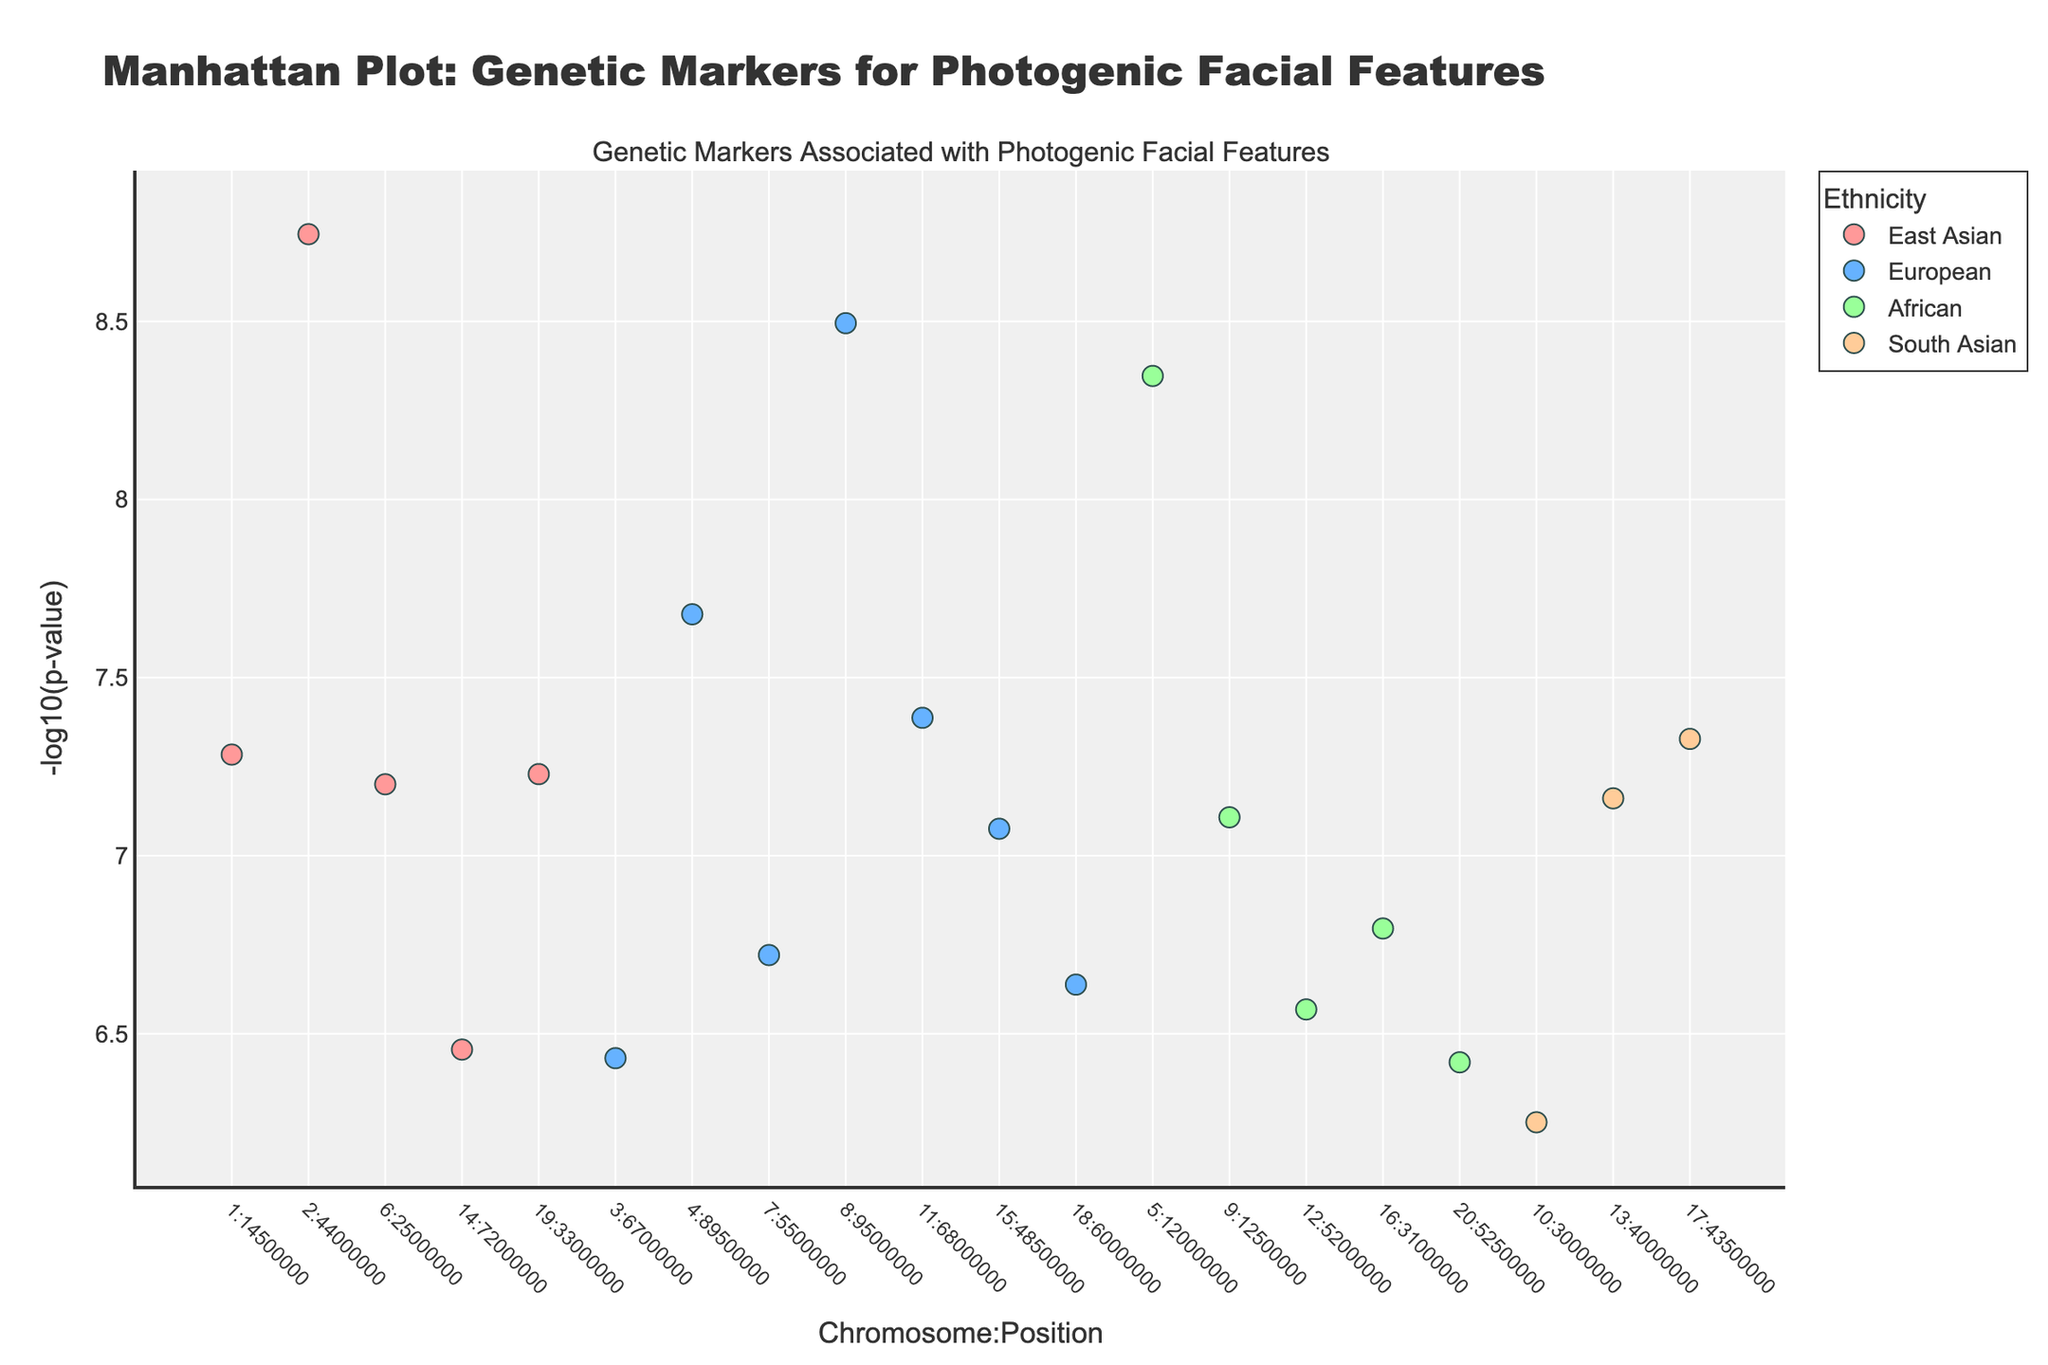What is the title of the plot? The title is located at the top of the plot and summarizes the content of the figure. It reads "Manhattan Plot: Genetic Markers for Photogenic Facial Features."
Answer: Manhattan Plot: Genetic Markers for Photogenic Facial Features How many data points represent European ethnicity? Identify all points within the legend labeled "European." Each color on the plot represents a different ethnicity, and there are six data points for European ethnicity.
Answer: 6 Which chromosome has the gene with the lowest P-value for East Asian ethnicity? To determine this, look for the East Asian markers (red points) and identify the point that is highest (represents lowest P-value). The gene with the lowest P-value is EDAR on chromosome 2.
Answer: Chromosome 2 What is the -log10(P-value) of the gene on Chromosome 1 for East Asian ethnicity? Identify the red points (East Asian ethnicity) on Chromosome 1 and read the y-value off the plot. The P-value for the MFAP2 gene on Chromosome 1 is 5.2e-8, so -log10(P-value) would be around 7.28.
Answer: 7.28 Which ethnicities have genetic markers on Chromosome 5? Look for points on Chromosome 5 and identify their colors. The plot shows markers for African (green).
Answer: African Which ethnicity has the most genes associated with photogenic facial features? Count the number of data points for each ethnicity according to the legend. European ethnicity has the most points with a total of six.
Answer: European Is there a genetic marker on Chromosome 10? If yes, what ethnicity does it belong to? Look for any markers on Chromosome 10. There is one marker, identified by its color (orange), indicating it belongs to South Asian ethnicity.
Answer: South Asian Which gene on Chromosome 7 has the highest -log10(P-value) and to which ethnicity does it belong? Identify the point on Chromosome 7 and read its label. The gene GLI3 belongs to European ethnicity and has the highest -log10(P-value) for that chromosome.
Answer: GLI3, European Between Chromosome 13 and Chromosome 14, which one has the gene with the higher -log10(P-value) and what is the gene name? Compare the -log10(P-values) of markers on Chromosome 13 (EDNRB from South Asian) and on Chromosome 14 (PAX9 from East Asian). EDNRB on Chromosome 13 has a higher -log10(P-value) of 6.161.
Answer: Chromosome 13, EDNRB 